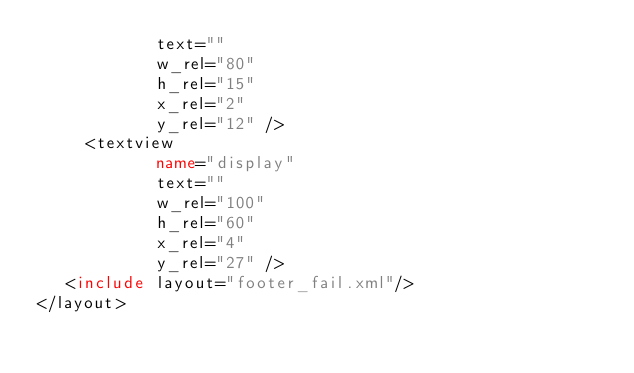<code> <loc_0><loc_0><loc_500><loc_500><_XML_>            text=""
            w_rel="80"
            h_rel="15"
            x_rel="2"
            y_rel="12" />
	 <textview
            name="display"
            text=""
            w_rel="100"
            h_rel="60"
            x_rel="4"
            y_rel="27" />
   <include layout="footer_fail.xml"/>
</layout>
</code> 